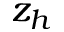Convert formula to latex. <formula><loc_0><loc_0><loc_500><loc_500>z _ { h }</formula> 